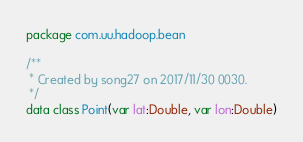Convert code to text. <code><loc_0><loc_0><loc_500><loc_500><_Kotlin_>package com.uu.hadoop.bean

/**
 * Created by song27 on 2017/11/30 0030.
 */
data class Point(var lat:Double, var lon:Double)</code> 